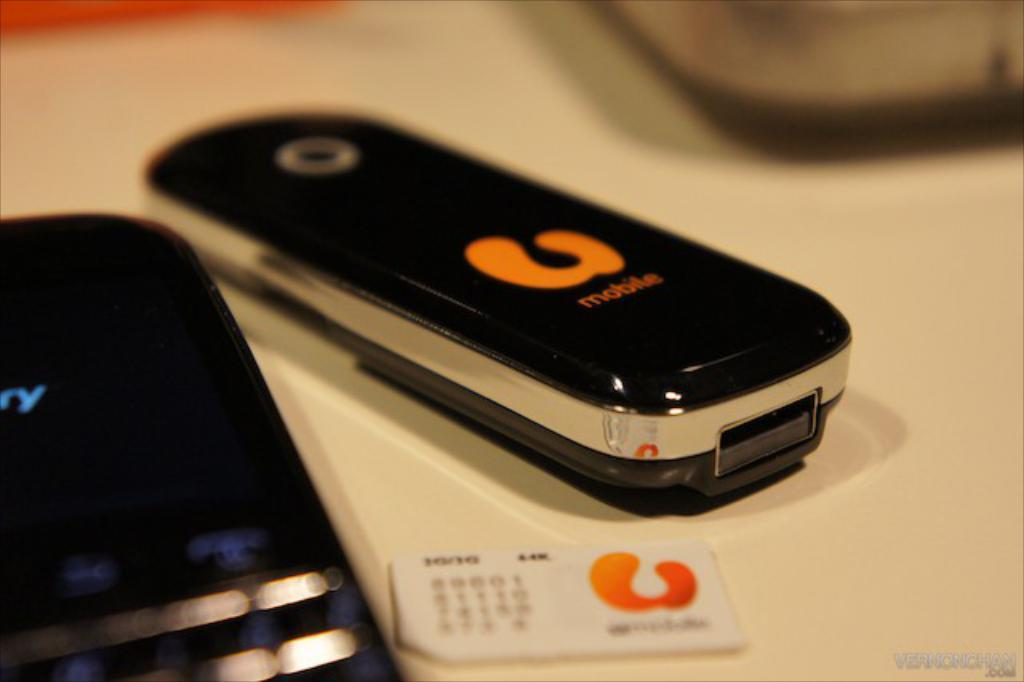<image>
Present a compact description of the photo's key features. Two cell phones including one Blackberry and a business card 